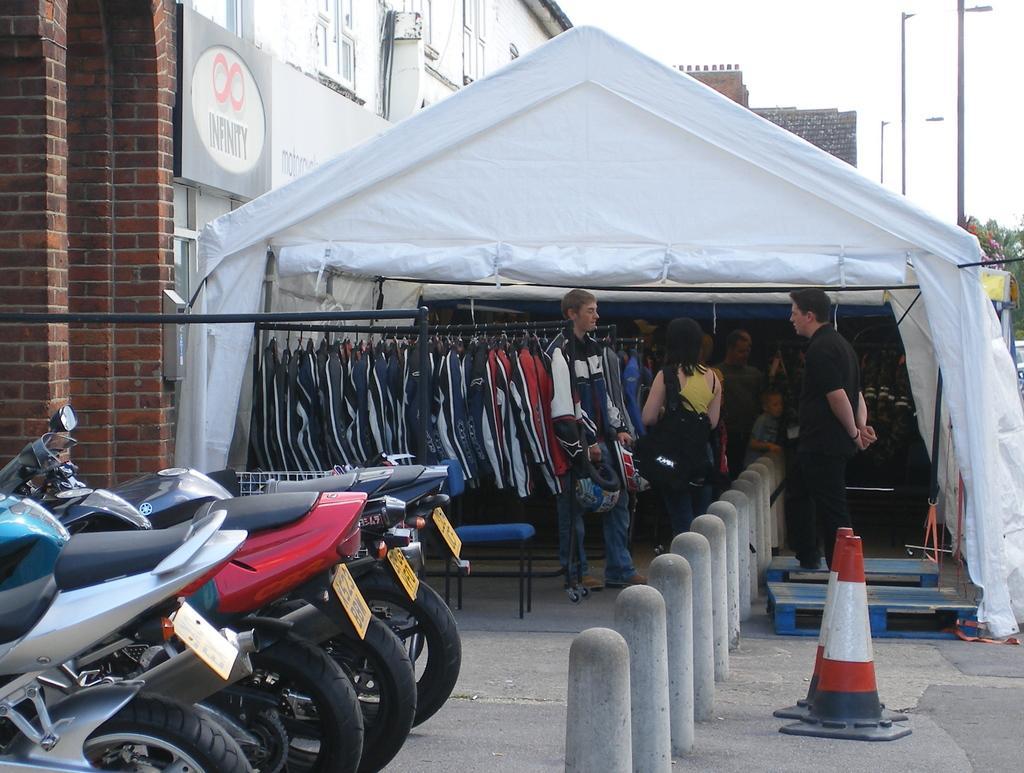Describe this image in one or two sentences. In this image we can see some clothes hanged under a tent. We can also see some pope beside that. On the left side we can see some two wheeler vehicles parked aside. On the right side we can see a pole and the divider poles. On the backside we can see a house with windows and the sky which looks cloudy. 